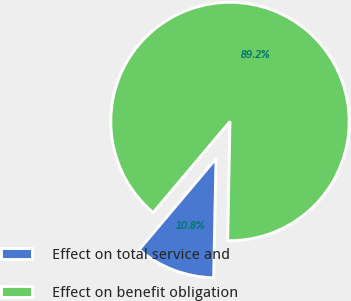<chart> <loc_0><loc_0><loc_500><loc_500><pie_chart><fcel>Effect on total service and<fcel>Effect on benefit obligation<nl><fcel>10.84%<fcel>89.16%<nl></chart> 